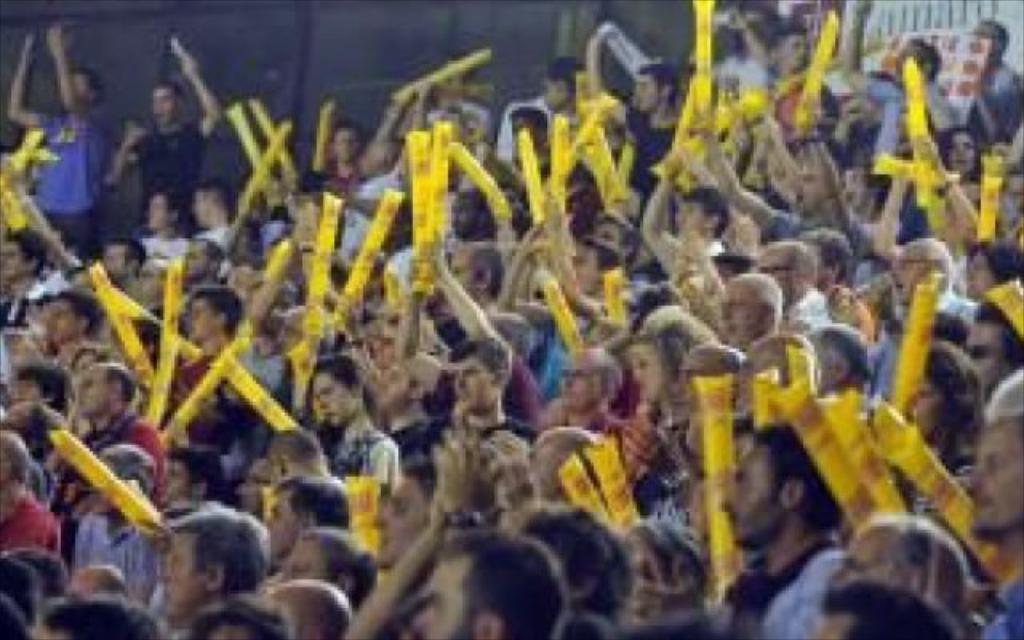Who or what is present in the image? There are people in the image. What are the people holding in the image? The people are holding yellow balloons. What can be seen in the background or surrounding the people? There is fencing visible in the image. Where is the grandmother's kettle located in the image? There is no mention of a grandmother or a kettle in the image, so we cannot determine its location. 